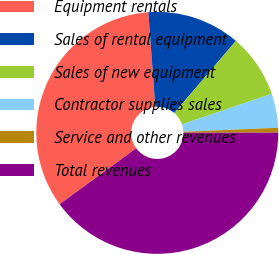<chart> <loc_0><loc_0><loc_500><loc_500><pie_chart><fcel>Equipment rentals<fcel>Sales of rental equipment<fcel>Sales of new equipment<fcel>Contractor supplies sales<fcel>Service and other revenues<fcel>Total revenues<nl><fcel>33.87%<fcel>12.44%<fcel>8.5%<fcel>4.57%<fcel>0.63%<fcel>39.99%<nl></chart> 